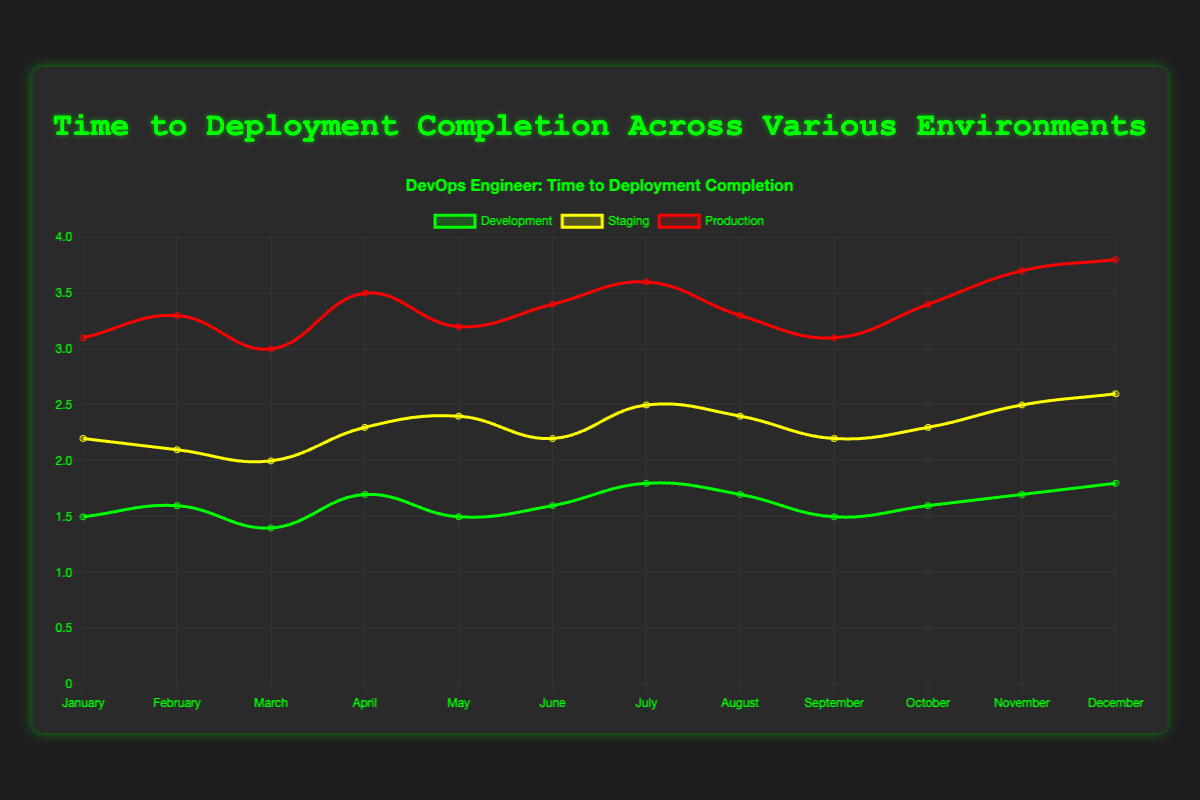What is the average time to deployment completion in the Production environment for the first quarter of the year? First quarter includes January, February, and March. Add the times: 3.1 + 3.3 + 3.0 = 9.4 hours, then divide by 3.
Answer: 3.13 hours Which environment had the highest time to deployment completion in April, and what was that time? Refer to April for all environments: Development (1.7), Staging (2.3), Production (3.5). Production has the highest time of 3.5 hours.
Answer: Production, 3.5 hours What is the difference in the time to deployment completion between Development and Staging environments in November? For November: Development (1.7), Staging (2.5). Subtract Development from Staging: 2.5 - 1.7 = 0.8 hours.
Answer: 0.8 hours Is there any month where the time to deployment completion in Development is equal to or more than in Staging? By comparing the times month-wise: Development is never equal to or more than Staging in any month.
Answer: No Which month experienced the shortest time to deployment completion in Production? Review the Production times for all months: the shortest time is in March with 3.0 hours.
Answer: March During June, what is the combined time for deployment completion across all environments? Add the times in June: Development (1.6) + Staging (2.2) + Production (3.4) = 7.2 hours.
Answer: 7.2 hours How did the time to deployment completion in the Staging environment change from January to December? January (2.2) to December (2.6). December's time is higher than January's by 2.6 - 2.2 = 0.4 hours.
Answer: Increased, 0.4 hours Which month saw the least variation in deployment times across all environments? Calculate the variation for each month and compare: the least variation occurs in March: Development (1.4), Staging (2.0), Production (3.0) with a range of 3.0 - 1.4 = 1.6 hours.
Answer: March What's the average time to deployment completion across all environments for the month of May? May times are: Development (1.5), Staging (2.4), Production (3.2). Sum them: 1.5 + 2.4 + 3.2 = 7.1 hours, then divide by 3.
Answer: 2.37 hours 